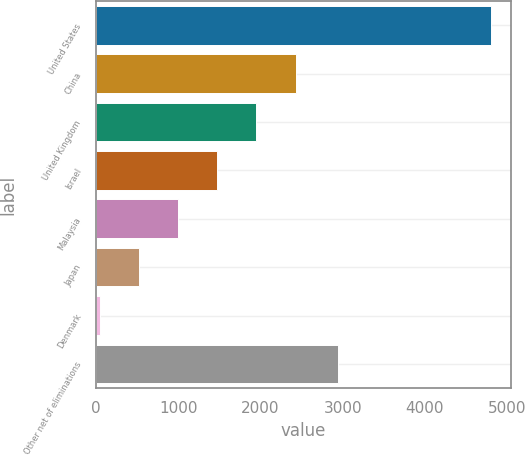<chart> <loc_0><loc_0><loc_500><loc_500><bar_chart><fcel>United States<fcel>China<fcel>United Kingdom<fcel>Israel<fcel>Malaysia<fcel>Japan<fcel>Denmark<fcel>Other net of eliminations<nl><fcel>4807<fcel>2425.5<fcel>1949.2<fcel>1472.9<fcel>996.6<fcel>520.3<fcel>44<fcel>2941<nl></chart> 